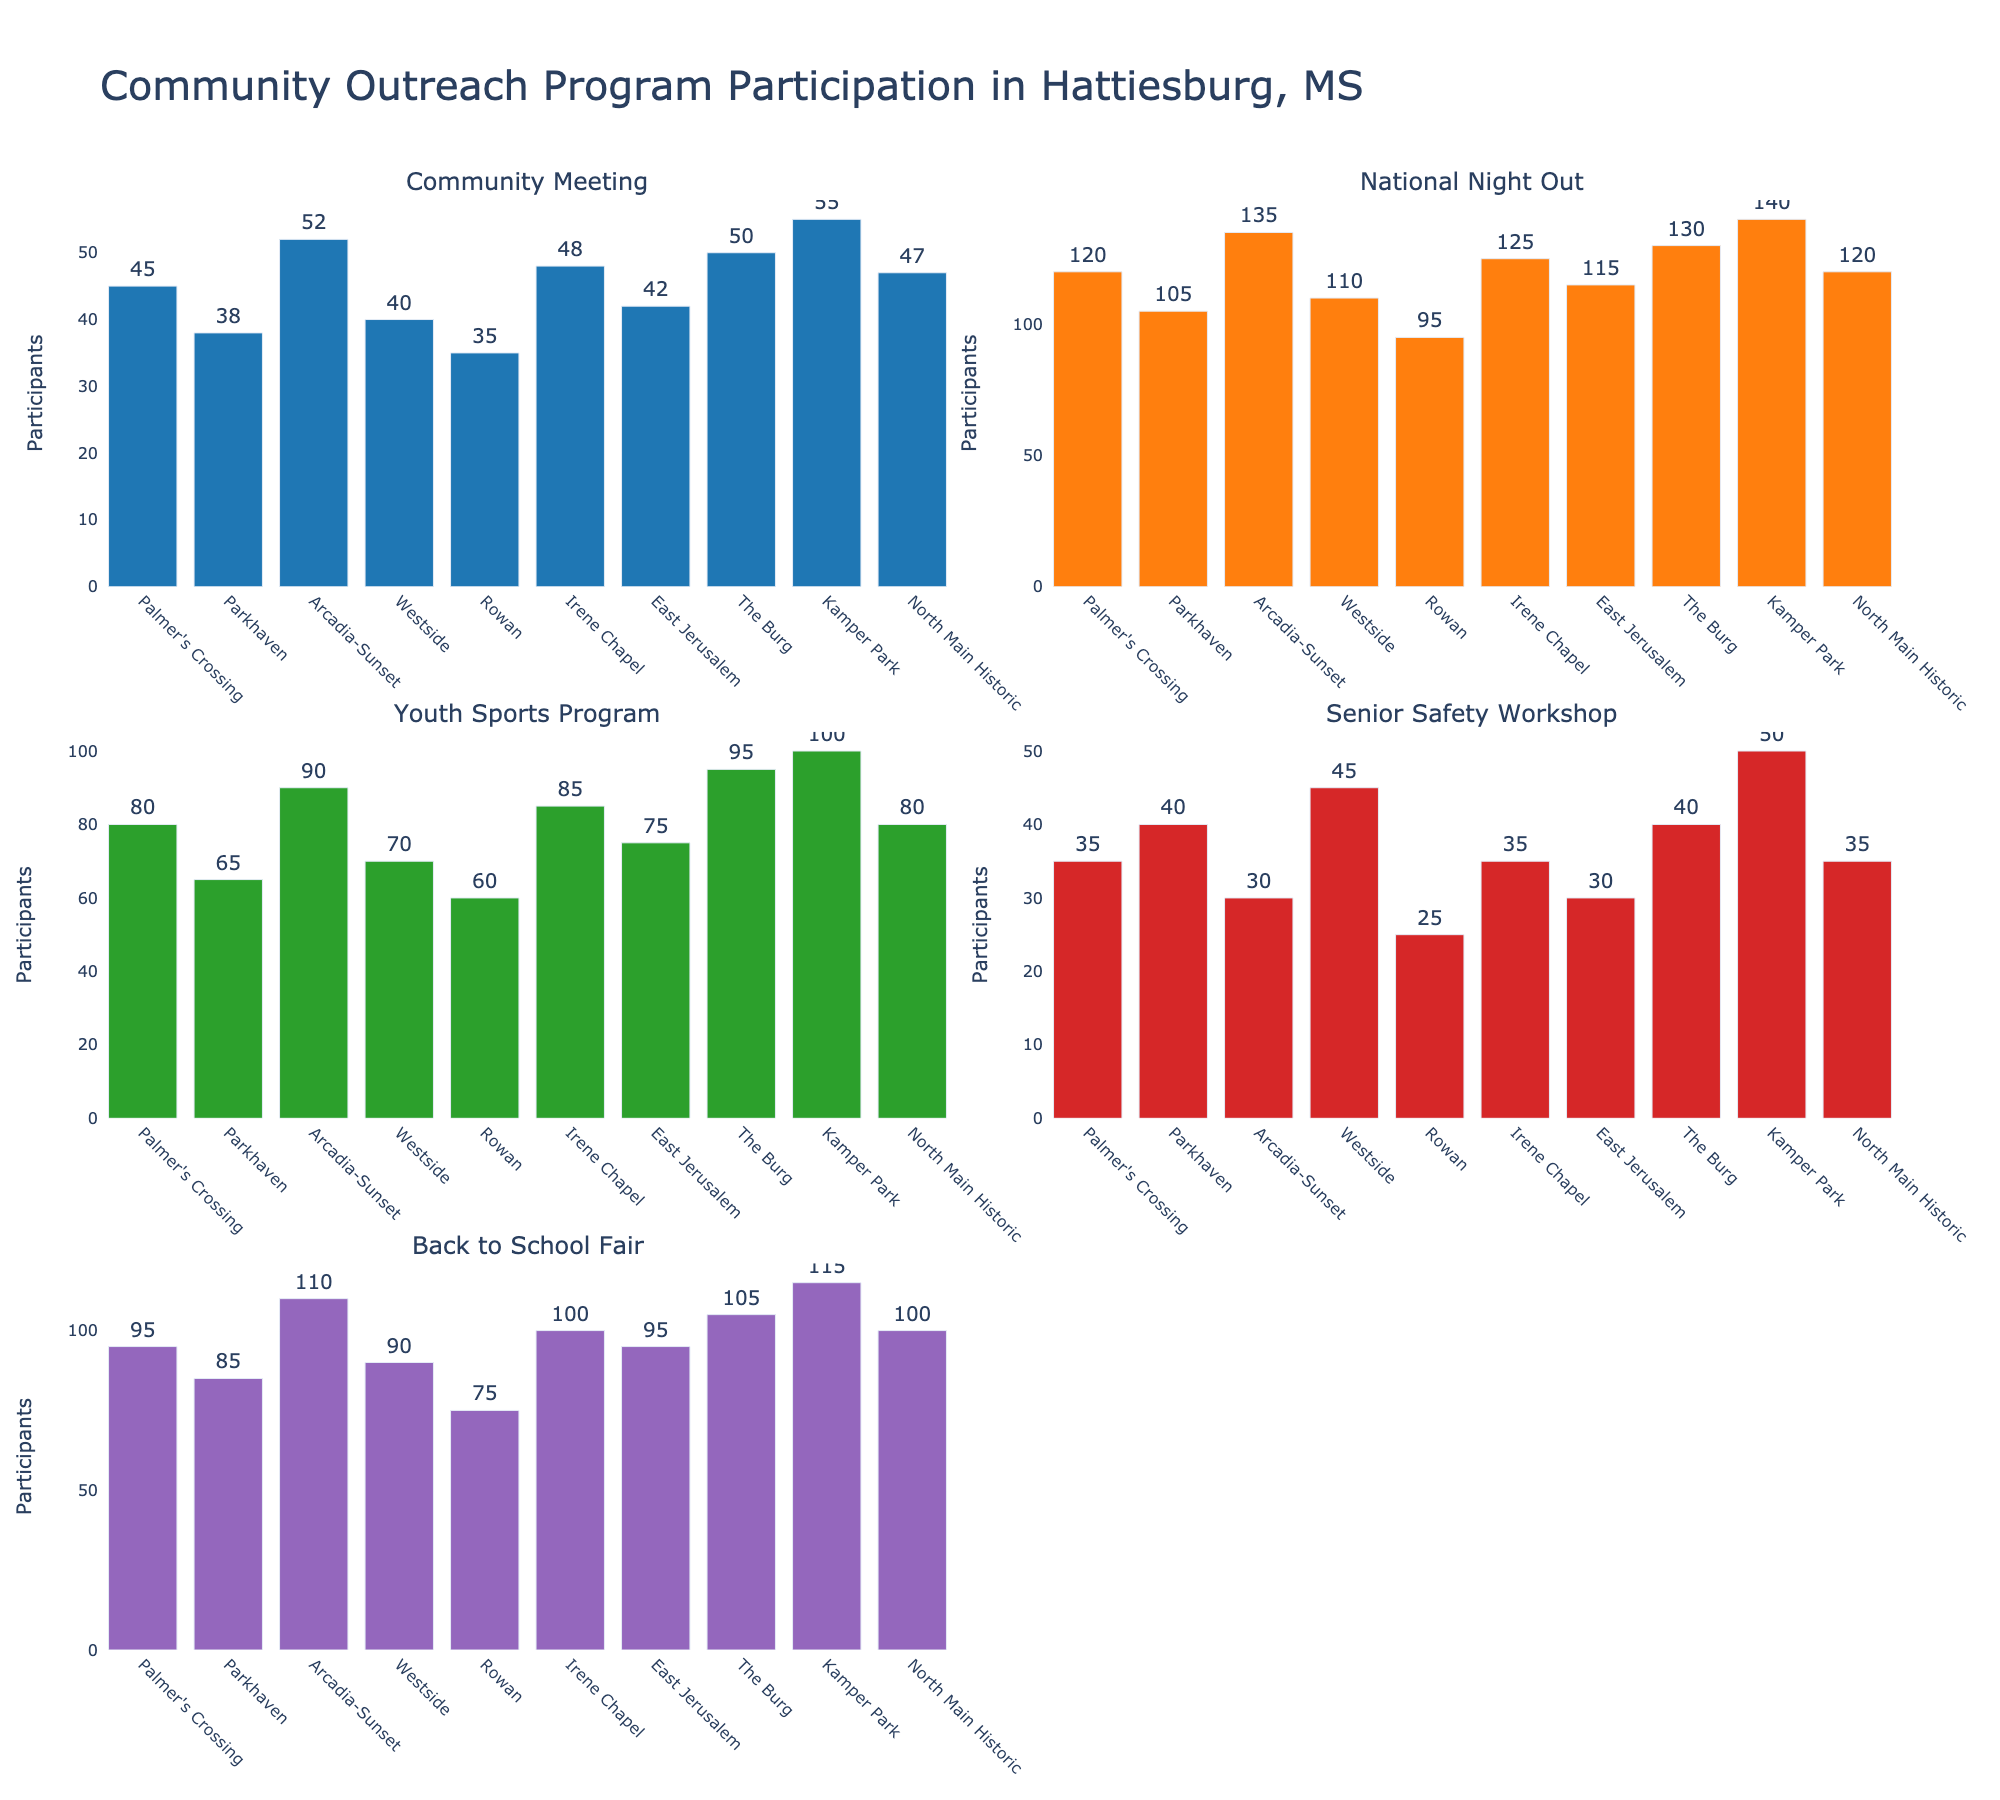What is the title of the figure? The title of the figure is located at the top and describes the overall theme of the plot.
Answer: Community Outreach Program Participation in Hattiesburg, MS Which neighborhood has the highest participation in National Night Out? Look at the bar corresponding to National Night Out and find the neighborhood with the tallest bar.
Answer: Kamper Park What is the average participation in the Youth Sports Program across all neighborhoods? Sum the participation numbers for the Youth Sports Program and then divide by the number of neighborhoods. (80 + 65 + 90 + 70 + 60 + 85 + 75 + 95 + 100 + 80) / 10 = 80
Answer: 80 Which event has the lowest participation in Westside? Compare the heights of all bars corresponding to Westside in each subplot and identify the shortest one.
Answer: Senior Safety Workshop How many participants attended the Community Meeting in Irene Chapel and East Jerusalem combined? Add the numbers for Community Meeting participation in Irene Chapel and East Jerusalem. 48 + 42 = 90
Answer: 90 How does the participation in the Back to School Fair in Palmer's Crossing compare to that in Rowan? Compare heights of bars for the Back to School Fair in Palmer's Crossing and Rowan. Palmer's Crossing has 95 participants and Rowan has 75. Palmer's Crossing has 20 more participants.
Answer: Palmer's Crossing has 20 more participants than Rowan Which event had the most uniform participation across all neighborhoods? Check the consistency of bar heights across subplots to identify the event with the least variability.
Answer: Community Meeting Calculate the difference in participation in the Senior Safety Workshop between Kamper Park and North Main Historic. Subtract the participation in North Main Historic from the participation in Kamper Park for the Senior Safety Workshop. 50 - 35 = 15
Answer: 15 Which neighborhood has the highest overall participation if you sum all events? Sum the participation numbers for all events per neighborhood and compare totals. Kamper Park has the highest total (55 + 140 + 100 + 50 + 115 = 460).
Answer: Kamper Park Is the participation in National Night Out generally higher than in the Community Meeting? Compare the average heights of bars for National Night Out and Community Meeting across all neighborhoods. The bars for National Night Out are generally taller, indicating higher participation.
Answer: Yes 